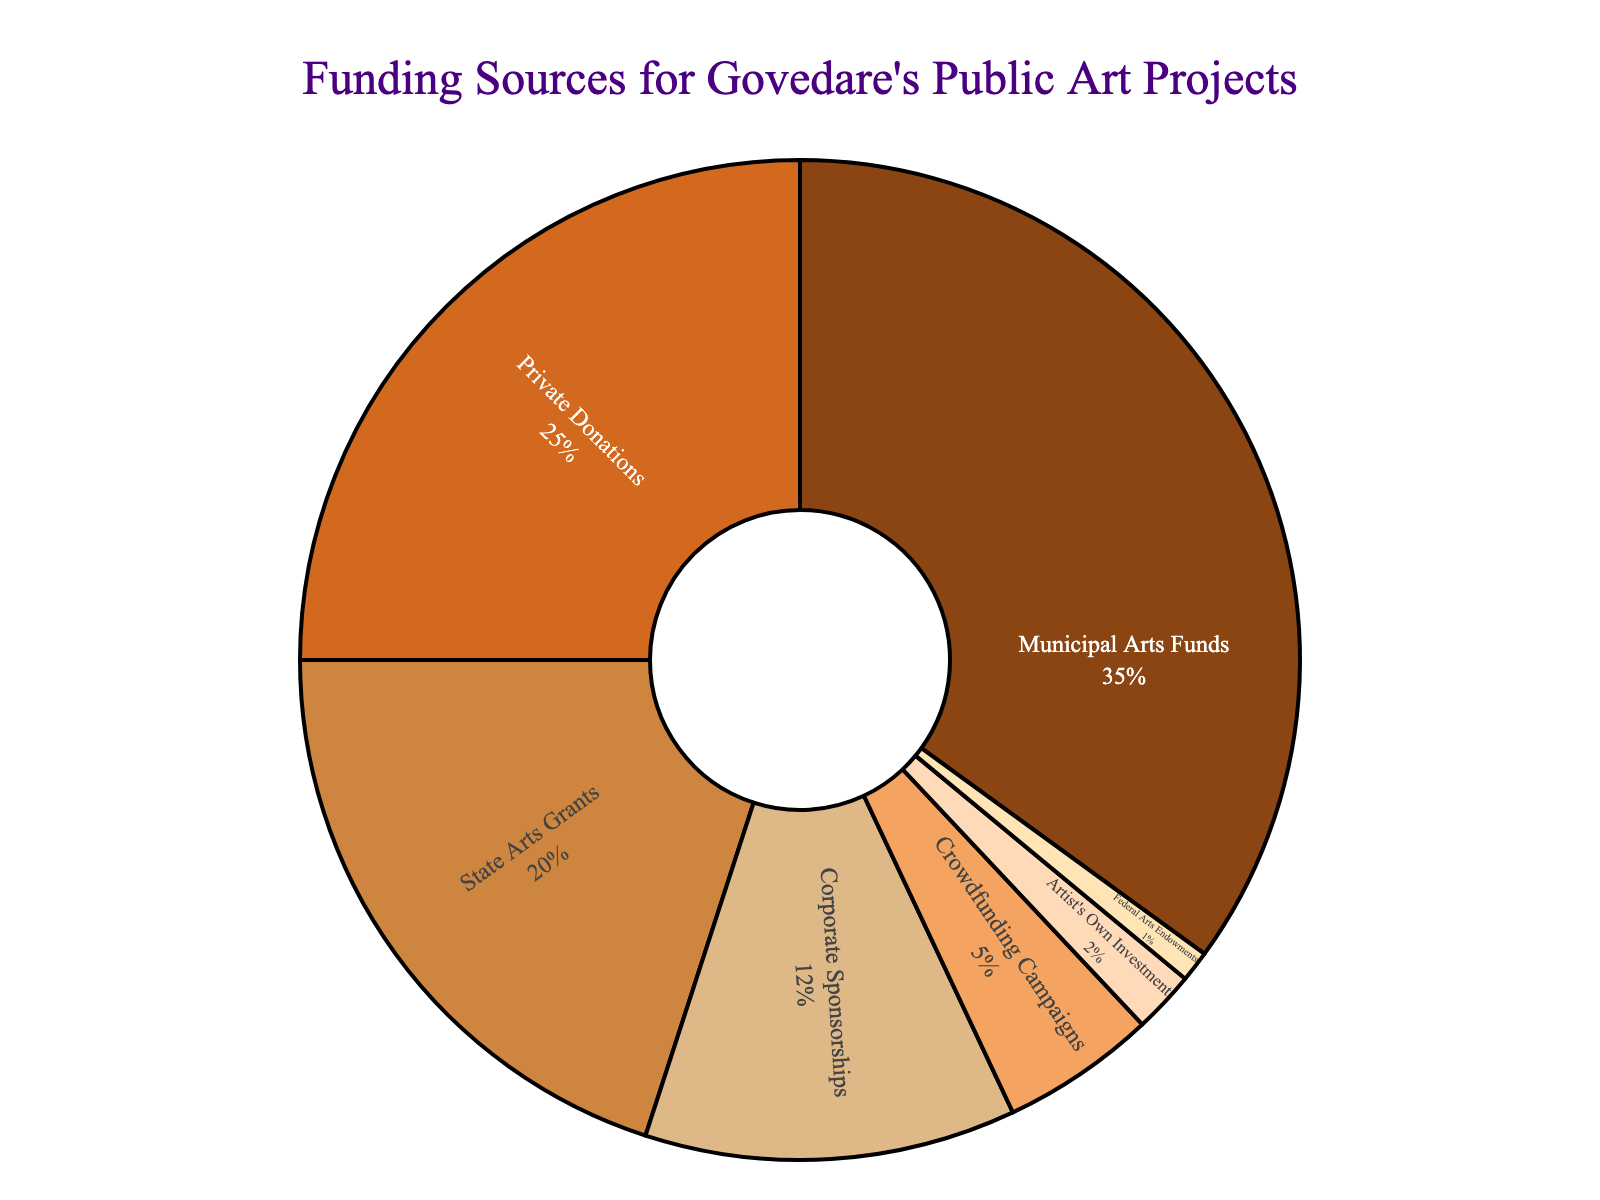How much more funding is provided by Municipal Arts Funds compared to Crowdfunding Campaigns? First, note the percentage contributions: Municipal Arts Funds = 35% and Crowdfunding Campaigns = 5%. Subtract the smaller percentage from the larger one (35% - 5%).
Answer: 30% Which funding source provides the smallest percentage of total funding? Look at the pie chart to identify the smallest sector, which corresponds to Federal Arts Endowments at 1%.
Answer: Federal Arts Endowments What is the combined percentage of funding from Private Donations and Corporate Sponsorships? Add the percentages of Private Donations (25%) and Corporate Sponsorships (12%). The combined total is 25% + 12%.
Answer: 37% How does the combined funding from State Arts Grants and Federal Arts Endowments compare to Private Donations alone? First, sum State Arts Grants (20%) and Federal Arts Endowments (1%) to get 21%. Compare this to Private Donations (25%), noting that 21% is less than 25%.
Answer: Less What percentage of funding comes from sources other than Municipal Arts Funds? Subtract the percentage for Municipal Arts Funds (35%) from 100% to find the rest. 100% - 35% = 65%.
Answer: 65% Which category of funding has the third highest percentage? Observe the size of the segments in descending order. The third largest segment represents State Arts Grants at 20%.
Answer: State Arts Grants What is the total percentage contributed by the top two funding sources? Identify the top two segments: Municipal Arts Funds (35%) and Private Donations (25%). Add these percentages together: 35% + 25%.
Answer: 60% What color represents the Artist's Own Investment in the pie chart? Look for the segment representing 2% labeled Artist's Own Investment and note its color, which is a peach-like (#FFDAB9).
Answer: Peach By what percentage does Corporate Sponsorships exceed Crowdfunding Campaigns? Subtract the percentage of Crowdfunding Campaigns (5%) from Corporate Sponsorships (12%). 12% - 5%.
Answer: 7% How many funding categories contribute 10% or more? Count the segments with percentages 10% or higher: Municipal Arts Funds (35%), Private Donations (25%), State Arts Grants (20%), and Corporate Sponsorships (12%).
Answer: 4 